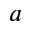<formula> <loc_0><loc_0><loc_500><loc_500>a</formula> 